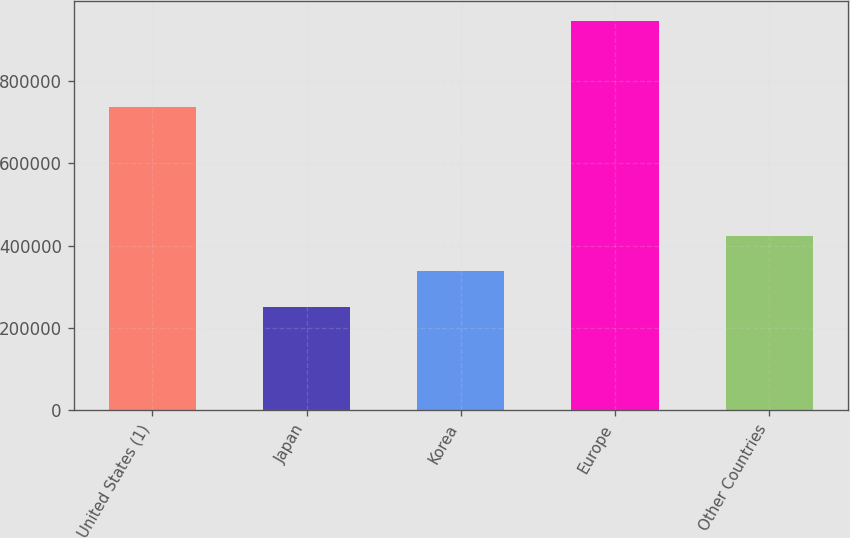<chart> <loc_0><loc_0><loc_500><loc_500><bar_chart><fcel>United States (1)<fcel>Japan<fcel>Korea<fcel>Europe<fcel>Other Countries<nl><fcel>736566<fcel>251673<fcel>339740<fcel>945836<fcel>423214<nl></chart> 